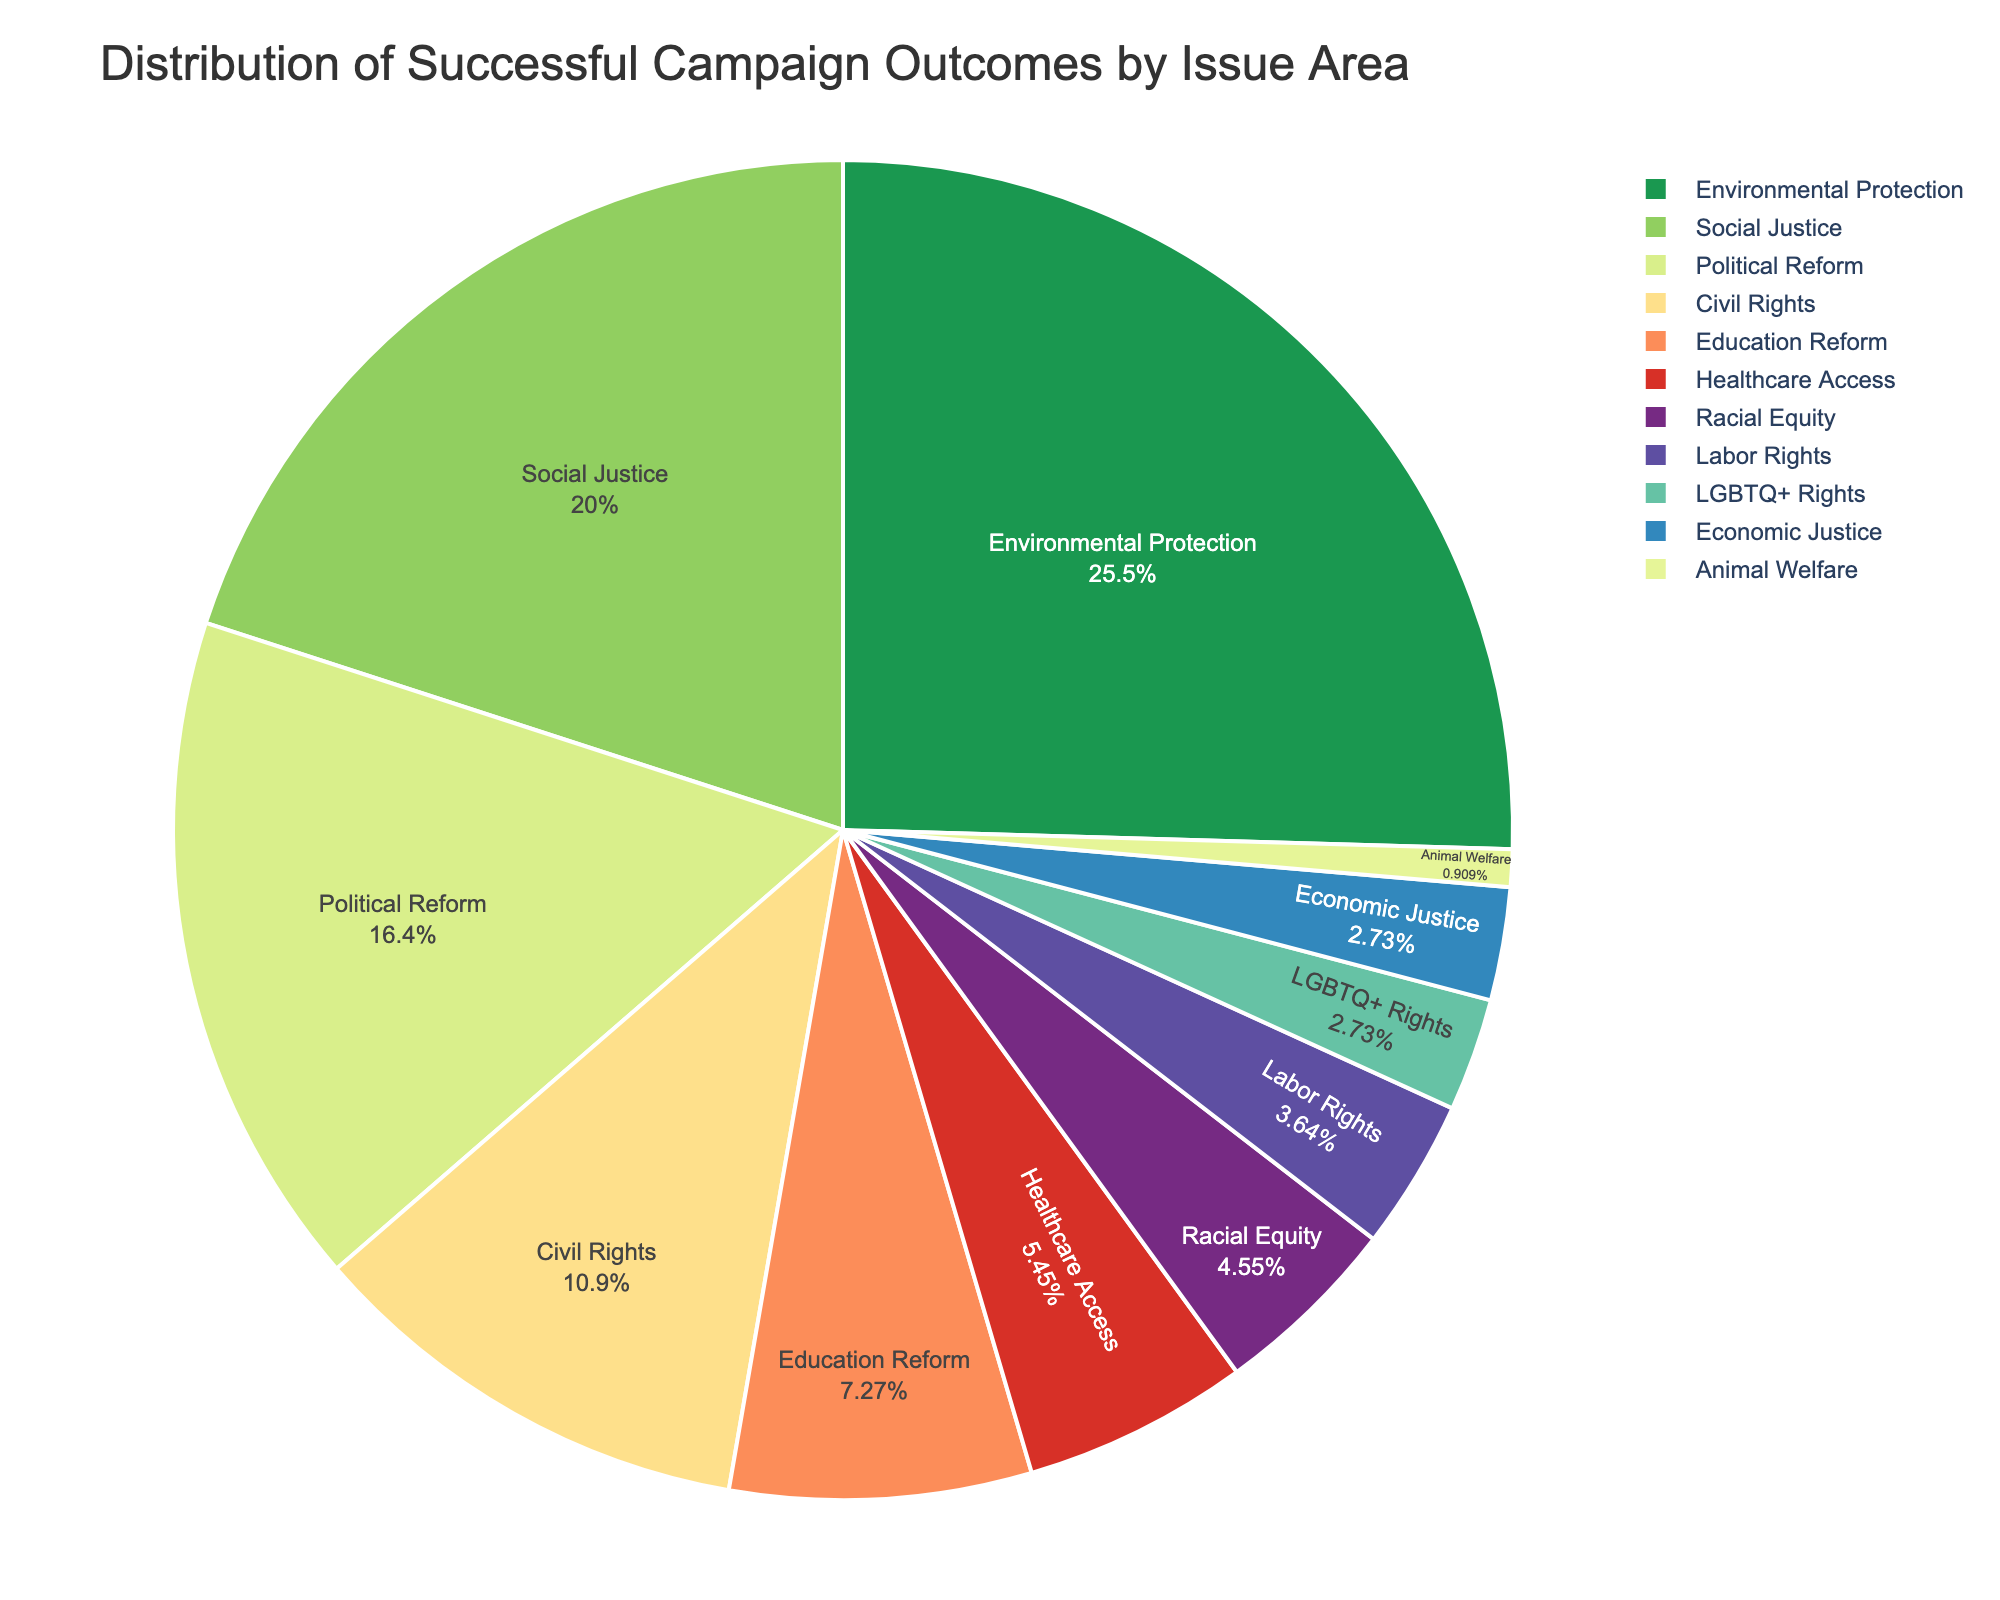Which issue area has the largest percentage of successful campaign outcomes? The largest percentage is the biggest section in the pie chart. It is labeled "Environmental Protection" with 28%.
Answer: Environmental Protection What is the combined percentage of successful campaigns for Social Justice and Political Reform? Add the percentages of Social Justice (22%) and Political Reform (18%): 22% + 18% = 40%.
Answer: 40% How many more successful campaign outcomes are there for Environmental Protection compared to Healthcare Access? Subtract the percentage for Healthcare Access (6%) from Environmental Protection (28%): 28% - 6% = 22%.
Answer: 22% Which issue area has exactly 8% of successful campaign outcomes? Look for the wedge labeled with 8%, which corresponds to Education Reform.
Answer: Education Reform Compare the percentages of successful campaigns for Civil Rights and Labor Rights. Which one has a higher percentage? Civil Rights has 12% while Labor Rights has 4%. 12% is higher than 4%.
Answer: Civil Rights Which issue area has the smallest percentage of successful campaign outcomes? The smallest wedge in the chart is labeled "Animal Welfare" with 1%.
Answer: Animal Welfare What percentage of successful campaign outcomes fall under issues not related to social justice or political reform? Calculate the sum of the percentages for all areas except Social Justice (22%) and Political Reform (18%): 100% - (22% + 18%) = 60%.
Answer: 60% By what percentage does the success rate for Racial Equity differ from LGBTQ+ Rights? Subtract the percentage of LGBTQ+ Rights (3%) from Racial Equity (5%): 5% - 3% = 2%.
Answer: 2% What are the percentages for the top three issue areas with the highest successful campaign outcomes? Identify and list the three largest sections: Environmental Protection (28%), Social Justice (22%), and Political Reform (18%).
Answer: 28%, 22%, 18% Add the percentages for Labor Rights, LGBTQ+ Rights, and Economic Justice. What is the total? Add the percentages: Labor Rights (4%) + LGBTQ+ Rights (3%) + Economic Justice (3%): 4% + 3% + 3% = 10%.
Answer: 10% 